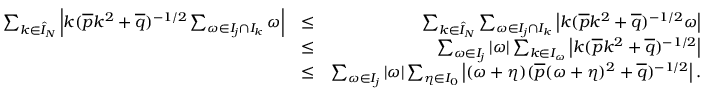Convert formula to latex. <formula><loc_0><loc_0><loc_500><loc_500>\begin{array} { r l r } { \sum _ { k \in \hat { I } _ { N } } \left | k ( \overline { p } k ^ { 2 } + \overline { q } ) ^ { - 1 / 2 } \sum _ { \omega \in I _ { j } \cap I _ { k } } \omega \right | } & { \leq } & { \sum _ { k \in \hat { I } _ { N } } \sum _ { \omega \in I _ { j } \cap I _ { k } } \left | k ( \overline { p } k ^ { 2 } + \overline { q } ) ^ { - 1 / 2 } \omega \right | } \\ & { \leq } & { \sum _ { \omega \in I _ { j } } | \omega | \sum _ { k \in I _ { \omega } } \left | k ( \overline { p } k ^ { 2 } + \overline { q } ) ^ { - 1 / 2 } \right | } \\ & { \leq } & { \sum _ { \omega \in I _ { j } } | \omega | \sum _ { \eta \in I _ { 0 } } \left | ( \omega + \eta ) ( \overline { p } ( \omega + \eta ) ^ { 2 } + \overline { q } ) ^ { - 1 / 2 } \right | . } \end{array}</formula> 